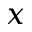<formula> <loc_0><loc_0><loc_500><loc_500>x</formula> 